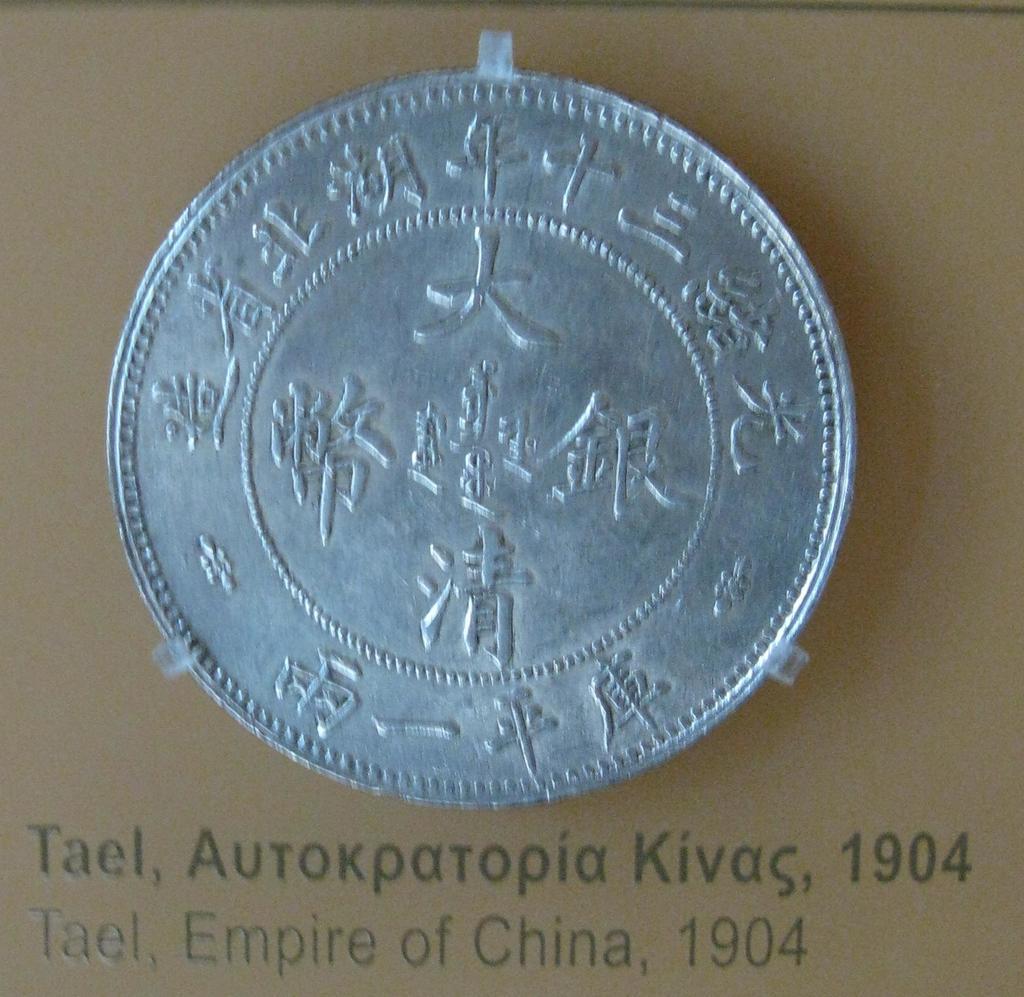What year is this coin?
Ensure brevity in your answer.  1904. When was this coin minted?
Your answer should be compact. 1904. 